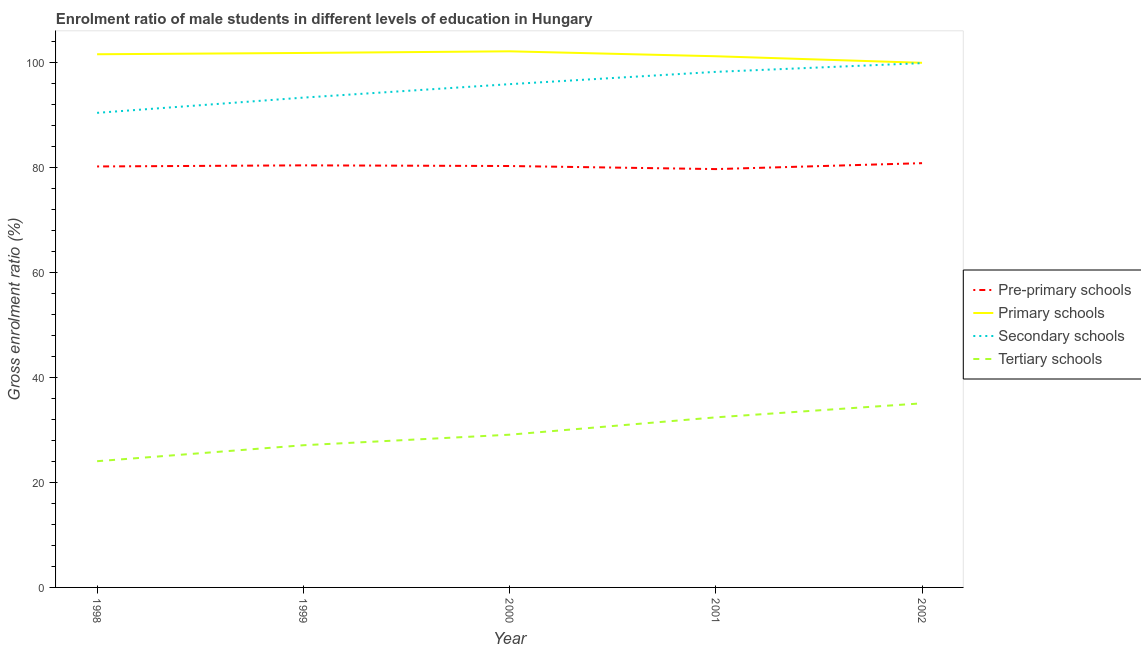How many different coloured lines are there?
Provide a short and direct response. 4. Does the line corresponding to gross enrolment ratio(female) in pre-primary schools intersect with the line corresponding to gross enrolment ratio(female) in tertiary schools?
Give a very brief answer. No. Is the number of lines equal to the number of legend labels?
Offer a terse response. Yes. What is the gross enrolment ratio(female) in pre-primary schools in 2001?
Offer a very short reply. 79.65. Across all years, what is the maximum gross enrolment ratio(female) in pre-primary schools?
Make the answer very short. 80.78. Across all years, what is the minimum gross enrolment ratio(female) in primary schools?
Ensure brevity in your answer.  99.89. What is the total gross enrolment ratio(female) in primary schools in the graph?
Your answer should be compact. 506.36. What is the difference between the gross enrolment ratio(female) in pre-primary schools in 1999 and that in 2000?
Your answer should be compact. 0.13. What is the difference between the gross enrolment ratio(female) in pre-primary schools in 2000 and the gross enrolment ratio(female) in primary schools in 1998?
Make the answer very short. -21.28. What is the average gross enrolment ratio(female) in primary schools per year?
Your answer should be compact. 101.27. In the year 2000, what is the difference between the gross enrolment ratio(female) in secondary schools and gross enrolment ratio(female) in pre-primary schools?
Provide a succinct answer. 15.58. What is the ratio of the gross enrolment ratio(female) in tertiary schools in 1999 to that in 2002?
Make the answer very short. 0.77. Is the gross enrolment ratio(female) in secondary schools in 1998 less than that in 2001?
Offer a terse response. Yes. Is the difference between the gross enrolment ratio(female) in tertiary schools in 1999 and 2002 greater than the difference between the gross enrolment ratio(female) in pre-primary schools in 1999 and 2002?
Provide a short and direct response. No. What is the difference between the highest and the second highest gross enrolment ratio(female) in primary schools?
Offer a terse response. 0.31. What is the difference between the highest and the lowest gross enrolment ratio(female) in secondary schools?
Offer a very short reply. 9.47. Is the sum of the gross enrolment ratio(female) in pre-primary schools in 2001 and 2002 greater than the maximum gross enrolment ratio(female) in primary schools across all years?
Offer a very short reply. Yes. Is it the case that in every year, the sum of the gross enrolment ratio(female) in secondary schools and gross enrolment ratio(female) in primary schools is greater than the sum of gross enrolment ratio(female) in pre-primary schools and gross enrolment ratio(female) in tertiary schools?
Make the answer very short. Yes. How many lines are there?
Provide a succinct answer. 4. What is the difference between two consecutive major ticks on the Y-axis?
Give a very brief answer. 20. Does the graph contain any zero values?
Offer a terse response. No. Where does the legend appear in the graph?
Provide a short and direct response. Center right. How are the legend labels stacked?
Provide a short and direct response. Vertical. What is the title of the graph?
Make the answer very short. Enrolment ratio of male students in different levels of education in Hungary. Does "Secondary general" appear as one of the legend labels in the graph?
Offer a terse response. No. What is the label or title of the X-axis?
Provide a short and direct response. Year. What is the Gross enrolment ratio (%) in Pre-primary schools in 1998?
Offer a terse response. 80.15. What is the Gross enrolment ratio (%) of Primary schools in 1998?
Offer a terse response. 101.51. What is the Gross enrolment ratio (%) in Secondary schools in 1998?
Make the answer very short. 90.36. What is the Gross enrolment ratio (%) in Tertiary schools in 1998?
Your answer should be very brief. 24.03. What is the Gross enrolment ratio (%) of Pre-primary schools in 1999?
Give a very brief answer. 80.36. What is the Gross enrolment ratio (%) in Primary schools in 1999?
Ensure brevity in your answer.  101.76. What is the Gross enrolment ratio (%) in Secondary schools in 1999?
Give a very brief answer. 93.26. What is the Gross enrolment ratio (%) in Tertiary schools in 1999?
Provide a succinct answer. 27.07. What is the Gross enrolment ratio (%) of Pre-primary schools in 2000?
Offer a terse response. 80.23. What is the Gross enrolment ratio (%) in Primary schools in 2000?
Your response must be concise. 102.07. What is the Gross enrolment ratio (%) in Secondary schools in 2000?
Make the answer very short. 95.82. What is the Gross enrolment ratio (%) of Tertiary schools in 2000?
Your answer should be compact. 29.08. What is the Gross enrolment ratio (%) in Pre-primary schools in 2001?
Ensure brevity in your answer.  79.65. What is the Gross enrolment ratio (%) in Primary schools in 2001?
Your response must be concise. 101.13. What is the Gross enrolment ratio (%) of Secondary schools in 2001?
Offer a terse response. 98.16. What is the Gross enrolment ratio (%) in Tertiary schools in 2001?
Provide a succinct answer. 32.38. What is the Gross enrolment ratio (%) of Pre-primary schools in 2002?
Ensure brevity in your answer.  80.78. What is the Gross enrolment ratio (%) of Primary schools in 2002?
Offer a terse response. 99.89. What is the Gross enrolment ratio (%) in Secondary schools in 2002?
Provide a succinct answer. 99.82. What is the Gross enrolment ratio (%) of Tertiary schools in 2002?
Make the answer very short. 35.05. Across all years, what is the maximum Gross enrolment ratio (%) in Pre-primary schools?
Offer a terse response. 80.78. Across all years, what is the maximum Gross enrolment ratio (%) in Primary schools?
Provide a succinct answer. 102.07. Across all years, what is the maximum Gross enrolment ratio (%) in Secondary schools?
Make the answer very short. 99.82. Across all years, what is the maximum Gross enrolment ratio (%) in Tertiary schools?
Offer a very short reply. 35.05. Across all years, what is the minimum Gross enrolment ratio (%) of Pre-primary schools?
Offer a very short reply. 79.65. Across all years, what is the minimum Gross enrolment ratio (%) of Primary schools?
Your response must be concise. 99.89. Across all years, what is the minimum Gross enrolment ratio (%) of Secondary schools?
Provide a succinct answer. 90.36. Across all years, what is the minimum Gross enrolment ratio (%) in Tertiary schools?
Your response must be concise. 24.03. What is the total Gross enrolment ratio (%) in Pre-primary schools in the graph?
Offer a very short reply. 401.17. What is the total Gross enrolment ratio (%) of Primary schools in the graph?
Give a very brief answer. 506.36. What is the total Gross enrolment ratio (%) of Secondary schools in the graph?
Keep it short and to the point. 477.41. What is the total Gross enrolment ratio (%) of Tertiary schools in the graph?
Provide a short and direct response. 147.62. What is the difference between the Gross enrolment ratio (%) of Pre-primary schools in 1998 and that in 1999?
Offer a very short reply. -0.21. What is the difference between the Gross enrolment ratio (%) in Primary schools in 1998 and that in 1999?
Your response must be concise. -0.25. What is the difference between the Gross enrolment ratio (%) in Secondary schools in 1998 and that in 1999?
Your answer should be very brief. -2.9. What is the difference between the Gross enrolment ratio (%) of Tertiary schools in 1998 and that in 1999?
Give a very brief answer. -3.04. What is the difference between the Gross enrolment ratio (%) of Pre-primary schools in 1998 and that in 2000?
Your answer should be compact. -0.08. What is the difference between the Gross enrolment ratio (%) of Primary schools in 1998 and that in 2000?
Offer a terse response. -0.56. What is the difference between the Gross enrolment ratio (%) of Secondary schools in 1998 and that in 2000?
Keep it short and to the point. -5.46. What is the difference between the Gross enrolment ratio (%) in Tertiary schools in 1998 and that in 2000?
Provide a short and direct response. -5.05. What is the difference between the Gross enrolment ratio (%) of Pre-primary schools in 1998 and that in 2001?
Your response must be concise. 0.5. What is the difference between the Gross enrolment ratio (%) in Primary schools in 1998 and that in 2001?
Provide a succinct answer. 0.38. What is the difference between the Gross enrolment ratio (%) of Secondary schools in 1998 and that in 2001?
Give a very brief answer. -7.8. What is the difference between the Gross enrolment ratio (%) of Tertiary schools in 1998 and that in 2001?
Your answer should be compact. -8.35. What is the difference between the Gross enrolment ratio (%) of Pre-primary schools in 1998 and that in 2002?
Your response must be concise. -0.63. What is the difference between the Gross enrolment ratio (%) in Primary schools in 1998 and that in 2002?
Give a very brief answer. 1.63. What is the difference between the Gross enrolment ratio (%) of Secondary schools in 1998 and that in 2002?
Keep it short and to the point. -9.47. What is the difference between the Gross enrolment ratio (%) of Tertiary schools in 1998 and that in 2002?
Provide a short and direct response. -11.02. What is the difference between the Gross enrolment ratio (%) of Pre-primary schools in 1999 and that in 2000?
Keep it short and to the point. 0.13. What is the difference between the Gross enrolment ratio (%) of Primary schools in 1999 and that in 2000?
Provide a short and direct response. -0.31. What is the difference between the Gross enrolment ratio (%) in Secondary schools in 1999 and that in 2000?
Provide a short and direct response. -2.56. What is the difference between the Gross enrolment ratio (%) in Tertiary schools in 1999 and that in 2000?
Offer a very short reply. -2.01. What is the difference between the Gross enrolment ratio (%) of Pre-primary schools in 1999 and that in 2001?
Your answer should be compact. 0.71. What is the difference between the Gross enrolment ratio (%) in Primary schools in 1999 and that in 2001?
Your answer should be compact. 0.63. What is the difference between the Gross enrolment ratio (%) of Secondary schools in 1999 and that in 2001?
Keep it short and to the point. -4.9. What is the difference between the Gross enrolment ratio (%) in Tertiary schools in 1999 and that in 2001?
Provide a short and direct response. -5.31. What is the difference between the Gross enrolment ratio (%) in Pre-primary schools in 1999 and that in 2002?
Make the answer very short. -0.42. What is the difference between the Gross enrolment ratio (%) in Primary schools in 1999 and that in 2002?
Give a very brief answer. 1.87. What is the difference between the Gross enrolment ratio (%) in Secondary schools in 1999 and that in 2002?
Provide a short and direct response. -6.57. What is the difference between the Gross enrolment ratio (%) in Tertiary schools in 1999 and that in 2002?
Ensure brevity in your answer.  -7.98. What is the difference between the Gross enrolment ratio (%) in Pre-primary schools in 2000 and that in 2001?
Provide a succinct answer. 0.58. What is the difference between the Gross enrolment ratio (%) of Primary schools in 2000 and that in 2001?
Your answer should be compact. 0.94. What is the difference between the Gross enrolment ratio (%) in Secondary schools in 2000 and that in 2001?
Your answer should be compact. -2.34. What is the difference between the Gross enrolment ratio (%) of Tertiary schools in 2000 and that in 2001?
Offer a very short reply. -3.3. What is the difference between the Gross enrolment ratio (%) of Pre-primary schools in 2000 and that in 2002?
Your answer should be very brief. -0.54. What is the difference between the Gross enrolment ratio (%) in Primary schools in 2000 and that in 2002?
Ensure brevity in your answer.  2.18. What is the difference between the Gross enrolment ratio (%) of Secondary schools in 2000 and that in 2002?
Give a very brief answer. -4.01. What is the difference between the Gross enrolment ratio (%) of Tertiary schools in 2000 and that in 2002?
Provide a succinct answer. -5.97. What is the difference between the Gross enrolment ratio (%) of Pre-primary schools in 2001 and that in 2002?
Make the answer very short. -1.13. What is the difference between the Gross enrolment ratio (%) of Primary schools in 2001 and that in 2002?
Offer a terse response. 1.24. What is the difference between the Gross enrolment ratio (%) of Secondary schools in 2001 and that in 2002?
Make the answer very short. -1.66. What is the difference between the Gross enrolment ratio (%) in Tertiary schools in 2001 and that in 2002?
Give a very brief answer. -2.67. What is the difference between the Gross enrolment ratio (%) in Pre-primary schools in 1998 and the Gross enrolment ratio (%) in Primary schools in 1999?
Provide a succinct answer. -21.61. What is the difference between the Gross enrolment ratio (%) in Pre-primary schools in 1998 and the Gross enrolment ratio (%) in Secondary schools in 1999?
Provide a short and direct response. -13.11. What is the difference between the Gross enrolment ratio (%) in Pre-primary schools in 1998 and the Gross enrolment ratio (%) in Tertiary schools in 1999?
Keep it short and to the point. 53.08. What is the difference between the Gross enrolment ratio (%) in Primary schools in 1998 and the Gross enrolment ratio (%) in Secondary schools in 1999?
Give a very brief answer. 8.26. What is the difference between the Gross enrolment ratio (%) in Primary schools in 1998 and the Gross enrolment ratio (%) in Tertiary schools in 1999?
Provide a short and direct response. 74.44. What is the difference between the Gross enrolment ratio (%) in Secondary schools in 1998 and the Gross enrolment ratio (%) in Tertiary schools in 1999?
Keep it short and to the point. 63.29. What is the difference between the Gross enrolment ratio (%) in Pre-primary schools in 1998 and the Gross enrolment ratio (%) in Primary schools in 2000?
Ensure brevity in your answer.  -21.92. What is the difference between the Gross enrolment ratio (%) in Pre-primary schools in 1998 and the Gross enrolment ratio (%) in Secondary schools in 2000?
Make the answer very short. -15.67. What is the difference between the Gross enrolment ratio (%) of Pre-primary schools in 1998 and the Gross enrolment ratio (%) of Tertiary schools in 2000?
Make the answer very short. 51.07. What is the difference between the Gross enrolment ratio (%) in Primary schools in 1998 and the Gross enrolment ratio (%) in Secondary schools in 2000?
Ensure brevity in your answer.  5.7. What is the difference between the Gross enrolment ratio (%) of Primary schools in 1998 and the Gross enrolment ratio (%) of Tertiary schools in 2000?
Make the answer very short. 72.43. What is the difference between the Gross enrolment ratio (%) of Secondary schools in 1998 and the Gross enrolment ratio (%) of Tertiary schools in 2000?
Provide a short and direct response. 61.28. What is the difference between the Gross enrolment ratio (%) in Pre-primary schools in 1998 and the Gross enrolment ratio (%) in Primary schools in 2001?
Provide a short and direct response. -20.98. What is the difference between the Gross enrolment ratio (%) of Pre-primary schools in 1998 and the Gross enrolment ratio (%) of Secondary schools in 2001?
Ensure brevity in your answer.  -18.01. What is the difference between the Gross enrolment ratio (%) in Pre-primary schools in 1998 and the Gross enrolment ratio (%) in Tertiary schools in 2001?
Your answer should be compact. 47.77. What is the difference between the Gross enrolment ratio (%) of Primary schools in 1998 and the Gross enrolment ratio (%) of Secondary schools in 2001?
Offer a terse response. 3.35. What is the difference between the Gross enrolment ratio (%) in Primary schools in 1998 and the Gross enrolment ratio (%) in Tertiary schools in 2001?
Offer a terse response. 69.13. What is the difference between the Gross enrolment ratio (%) of Secondary schools in 1998 and the Gross enrolment ratio (%) of Tertiary schools in 2001?
Your answer should be compact. 57.97. What is the difference between the Gross enrolment ratio (%) in Pre-primary schools in 1998 and the Gross enrolment ratio (%) in Primary schools in 2002?
Your answer should be very brief. -19.74. What is the difference between the Gross enrolment ratio (%) of Pre-primary schools in 1998 and the Gross enrolment ratio (%) of Secondary schools in 2002?
Ensure brevity in your answer.  -19.67. What is the difference between the Gross enrolment ratio (%) in Pre-primary schools in 1998 and the Gross enrolment ratio (%) in Tertiary schools in 2002?
Offer a terse response. 45.1. What is the difference between the Gross enrolment ratio (%) in Primary schools in 1998 and the Gross enrolment ratio (%) in Secondary schools in 2002?
Ensure brevity in your answer.  1.69. What is the difference between the Gross enrolment ratio (%) of Primary schools in 1998 and the Gross enrolment ratio (%) of Tertiary schools in 2002?
Your answer should be compact. 66.46. What is the difference between the Gross enrolment ratio (%) of Secondary schools in 1998 and the Gross enrolment ratio (%) of Tertiary schools in 2002?
Make the answer very short. 55.31. What is the difference between the Gross enrolment ratio (%) of Pre-primary schools in 1999 and the Gross enrolment ratio (%) of Primary schools in 2000?
Keep it short and to the point. -21.71. What is the difference between the Gross enrolment ratio (%) in Pre-primary schools in 1999 and the Gross enrolment ratio (%) in Secondary schools in 2000?
Your answer should be very brief. -15.46. What is the difference between the Gross enrolment ratio (%) in Pre-primary schools in 1999 and the Gross enrolment ratio (%) in Tertiary schools in 2000?
Make the answer very short. 51.28. What is the difference between the Gross enrolment ratio (%) of Primary schools in 1999 and the Gross enrolment ratio (%) of Secondary schools in 2000?
Offer a very short reply. 5.94. What is the difference between the Gross enrolment ratio (%) in Primary schools in 1999 and the Gross enrolment ratio (%) in Tertiary schools in 2000?
Your answer should be very brief. 72.68. What is the difference between the Gross enrolment ratio (%) of Secondary schools in 1999 and the Gross enrolment ratio (%) of Tertiary schools in 2000?
Ensure brevity in your answer.  64.18. What is the difference between the Gross enrolment ratio (%) of Pre-primary schools in 1999 and the Gross enrolment ratio (%) of Primary schools in 2001?
Your answer should be very brief. -20.77. What is the difference between the Gross enrolment ratio (%) in Pre-primary schools in 1999 and the Gross enrolment ratio (%) in Secondary schools in 2001?
Keep it short and to the point. -17.8. What is the difference between the Gross enrolment ratio (%) in Pre-primary schools in 1999 and the Gross enrolment ratio (%) in Tertiary schools in 2001?
Offer a very short reply. 47.98. What is the difference between the Gross enrolment ratio (%) of Primary schools in 1999 and the Gross enrolment ratio (%) of Secondary schools in 2001?
Keep it short and to the point. 3.6. What is the difference between the Gross enrolment ratio (%) of Primary schools in 1999 and the Gross enrolment ratio (%) of Tertiary schools in 2001?
Your answer should be compact. 69.38. What is the difference between the Gross enrolment ratio (%) of Secondary schools in 1999 and the Gross enrolment ratio (%) of Tertiary schools in 2001?
Provide a succinct answer. 60.87. What is the difference between the Gross enrolment ratio (%) of Pre-primary schools in 1999 and the Gross enrolment ratio (%) of Primary schools in 2002?
Provide a succinct answer. -19.53. What is the difference between the Gross enrolment ratio (%) in Pre-primary schools in 1999 and the Gross enrolment ratio (%) in Secondary schools in 2002?
Keep it short and to the point. -19.46. What is the difference between the Gross enrolment ratio (%) of Pre-primary schools in 1999 and the Gross enrolment ratio (%) of Tertiary schools in 2002?
Give a very brief answer. 45.31. What is the difference between the Gross enrolment ratio (%) in Primary schools in 1999 and the Gross enrolment ratio (%) in Secondary schools in 2002?
Keep it short and to the point. 1.94. What is the difference between the Gross enrolment ratio (%) of Primary schools in 1999 and the Gross enrolment ratio (%) of Tertiary schools in 2002?
Give a very brief answer. 66.71. What is the difference between the Gross enrolment ratio (%) in Secondary schools in 1999 and the Gross enrolment ratio (%) in Tertiary schools in 2002?
Give a very brief answer. 58.2. What is the difference between the Gross enrolment ratio (%) in Pre-primary schools in 2000 and the Gross enrolment ratio (%) in Primary schools in 2001?
Ensure brevity in your answer.  -20.9. What is the difference between the Gross enrolment ratio (%) of Pre-primary schools in 2000 and the Gross enrolment ratio (%) of Secondary schools in 2001?
Keep it short and to the point. -17.93. What is the difference between the Gross enrolment ratio (%) of Pre-primary schools in 2000 and the Gross enrolment ratio (%) of Tertiary schools in 2001?
Your answer should be very brief. 47.85. What is the difference between the Gross enrolment ratio (%) in Primary schools in 2000 and the Gross enrolment ratio (%) in Secondary schools in 2001?
Your answer should be compact. 3.91. What is the difference between the Gross enrolment ratio (%) in Primary schools in 2000 and the Gross enrolment ratio (%) in Tertiary schools in 2001?
Provide a succinct answer. 69.69. What is the difference between the Gross enrolment ratio (%) of Secondary schools in 2000 and the Gross enrolment ratio (%) of Tertiary schools in 2001?
Keep it short and to the point. 63.44. What is the difference between the Gross enrolment ratio (%) in Pre-primary schools in 2000 and the Gross enrolment ratio (%) in Primary schools in 2002?
Make the answer very short. -19.65. What is the difference between the Gross enrolment ratio (%) in Pre-primary schools in 2000 and the Gross enrolment ratio (%) in Secondary schools in 2002?
Offer a very short reply. -19.59. What is the difference between the Gross enrolment ratio (%) of Pre-primary schools in 2000 and the Gross enrolment ratio (%) of Tertiary schools in 2002?
Your response must be concise. 45.18. What is the difference between the Gross enrolment ratio (%) of Primary schools in 2000 and the Gross enrolment ratio (%) of Secondary schools in 2002?
Ensure brevity in your answer.  2.25. What is the difference between the Gross enrolment ratio (%) of Primary schools in 2000 and the Gross enrolment ratio (%) of Tertiary schools in 2002?
Ensure brevity in your answer.  67.02. What is the difference between the Gross enrolment ratio (%) in Secondary schools in 2000 and the Gross enrolment ratio (%) in Tertiary schools in 2002?
Ensure brevity in your answer.  60.77. What is the difference between the Gross enrolment ratio (%) in Pre-primary schools in 2001 and the Gross enrolment ratio (%) in Primary schools in 2002?
Provide a short and direct response. -20.24. What is the difference between the Gross enrolment ratio (%) in Pre-primary schools in 2001 and the Gross enrolment ratio (%) in Secondary schools in 2002?
Provide a succinct answer. -20.17. What is the difference between the Gross enrolment ratio (%) in Pre-primary schools in 2001 and the Gross enrolment ratio (%) in Tertiary schools in 2002?
Provide a short and direct response. 44.6. What is the difference between the Gross enrolment ratio (%) in Primary schools in 2001 and the Gross enrolment ratio (%) in Secondary schools in 2002?
Provide a succinct answer. 1.31. What is the difference between the Gross enrolment ratio (%) in Primary schools in 2001 and the Gross enrolment ratio (%) in Tertiary schools in 2002?
Offer a terse response. 66.08. What is the difference between the Gross enrolment ratio (%) of Secondary schools in 2001 and the Gross enrolment ratio (%) of Tertiary schools in 2002?
Provide a succinct answer. 63.11. What is the average Gross enrolment ratio (%) of Pre-primary schools per year?
Give a very brief answer. 80.23. What is the average Gross enrolment ratio (%) in Primary schools per year?
Give a very brief answer. 101.27. What is the average Gross enrolment ratio (%) in Secondary schools per year?
Give a very brief answer. 95.48. What is the average Gross enrolment ratio (%) in Tertiary schools per year?
Your answer should be very brief. 29.52. In the year 1998, what is the difference between the Gross enrolment ratio (%) of Pre-primary schools and Gross enrolment ratio (%) of Primary schools?
Offer a very short reply. -21.36. In the year 1998, what is the difference between the Gross enrolment ratio (%) of Pre-primary schools and Gross enrolment ratio (%) of Secondary schools?
Offer a terse response. -10.21. In the year 1998, what is the difference between the Gross enrolment ratio (%) in Pre-primary schools and Gross enrolment ratio (%) in Tertiary schools?
Offer a terse response. 56.12. In the year 1998, what is the difference between the Gross enrolment ratio (%) in Primary schools and Gross enrolment ratio (%) in Secondary schools?
Keep it short and to the point. 11.16. In the year 1998, what is the difference between the Gross enrolment ratio (%) in Primary schools and Gross enrolment ratio (%) in Tertiary schools?
Keep it short and to the point. 77.48. In the year 1998, what is the difference between the Gross enrolment ratio (%) of Secondary schools and Gross enrolment ratio (%) of Tertiary schools?
Your answer should be very brief. 66.33. In the year 1999, what is the difference between the Gross enrolment ratio (%) in Pre-primary schools and Gross enrolment ratio (%) in Primary schools?
Keep it short and to the point. -21.4. In the year 1999, what is the difference between the Gross enrolment ratio (%) of Pre-primary schools and Gross enrolment ratio (%) of Secondary schools?
Make the answer very short. -12.9. In the year 1999, what is the difference between the Gross enrolment ratio (%) in Pre-primary schools and Gross enrolment ratio (%) in Tertiary schools?
Make the answer very short. 53.29. In the year 1999, what is the difference between the Gross enrolment ratio (%) in Primary schools and Gross enrolment ratio (%) in Secondary schools?
Provide a succinct answer. 8.5. In the year 1999, what is the difference between the Gross enrolment ratio (%) of Primary schools and Gross enrolment ratio (%) of Tertiary schools?
Offer a terse response. 74.69. In the year 1999, what is the difference between the Gross enrolment ratio (%) in Secondary schools and Gross enrolment ratio (%) in Tertiary schools?
Ensure brevity in your answer.  66.19. In the year 2000, what is the difference between the Gross enrolment ratio (%) of Pre-primary schools and Gross enrolment ratio (%) of Primary schools?
Your answer should be very brief. -21.84. In the year 2000, what is the difference between the Gross enrolment ratio (%) in Pre-primary schools and Gross enrolment ratio (%) in Secondary schools?
Keep it short and to the point. -15.58. In the year 2000, what is the difference between the Gross enrolment ratio (%) in Pre-primary schools and Gross enrolment ratio (%) in Tertiary schools?
Provide a succinct answer. 51.15. In the year 2000, what is the difference between the Gross enrolment ratio (%) in Primary schools and Gross enrolment ratio (%) in Secondary schools?
Provide a succinct answer. 6.25. In the year 2000, what is the difference between the Gross enrolment ratio (%) of Primary schools and Gross enrolment ratio (%) of Tertiary schools?
Your response must be concise. 72.99. In the year 2000, what is the difference between the Gross enrolment ratio (%) of Secondary schools and Gross enrolment ratio (%) of Tertiary schools?
Ensure brevity in your answer.  66.74. In the year 2001, what is the difference between the Gross enrolment ratio (%) of Pre-primary schools and Gross enrolment ratio (%) of Primary schools?
Your answer should be very brief. -21.48. In the year 2001, what is the difference between the Gross enrolment ratio (%) in Pre-primary schools and Gross enrolment ratio (%) in Secondary schools?
Make the answer very short. -18.51. In the year 2001, what is the difference between the Gross enrolment ratio (%) in Pre-primary schools and Gross enrolment ratio (%) in Tertiary schools?
Offer a terse response. 47.27. In the year 2001, what is the difference between the Gross enrolment ratio (%) in Primary schools and Gross enrolment ratio (%) in Secondary schools?
Offer a very short reply. 2.97. In the year 2001, what is the difference between the Gross enrolment ratio (%) in Primary schools and Gross enrolment ratio (%) in Tertiary schools?
Offer a terse response. 68.75. In the year 2001, what is the difference between the Gross enrolment ratio (%) of Secondary schools and Gross enrolment ratio (%) of Tertiary schools?
Your response must be concise. 65.78. In the year 2002, what is the difference between the Gross enrolment ratio (%) in Pre-primary schools and Gross enrolment ratio (%) in Primary schools?
Your answer should be compact. -19.11. In the year 2002, what is the difference between the Gross enrolment ratio (%) in Pre-primary schools and Gross enrolment ratio (%) in Secondary schools?
Offer a very short reply. -19.05. In the year 2002, what is the difference between the Gross enrolment ratio (%) of Pre-primary schools and Gross enrolment ratio (%) of Tertiary schools?
Offer a very short reply. 45.72. In the year 2002, what is the difference between the Gross enrolment ratio (%) of Primary schools and Gross enrolment ratio (%) of Secondary schools?
Keep it short and to the point. 0.06. In the year 2002, what is the difference between the Gross enrolment ratio (%) of Primary schools and Gross enrolment ratio (%) of Tertiary schools?
Your answer should be compact. 64.83. In the year 2002, what is the difference between the Gross enrolment ratio (%) in Secondary schools and Gross enrolment ratio (%) in Tertiary schools?
Your answer should be compact. 64.77. What is the ratio of the Gross enrolment ratio (%) of Secondary schools in 1998 to that in 1999?
Provide a succinct answer. 0.97. What is the ratio of the Gross enrolment ratio (%) of Tertiary schools in 1998 to that in 1999?
Keep it short and to the point. 0.89. What is the ratio of the Gross enrolment ratio (%) in Secondary schools in 1998 to that in 2000?
Your answer should be compact. 0.94. What is the ratio of the Gross enrolment ratio (%) in Tertiary schools in 1998 to that in 2000?
Offer a terse response. 0.83. What is the ratio of the Gross enrolment ratio (%) of Primary schools in 1998 to that in 2001?
Ensure brevity in your answer.  1. What is the ratio of the Gross enrolment ratio (%) of Secondary schools in 1998 to that in 2001?
Your answer should be very brief. 0.92. What is the ratio of the Gross enrolment ratio (%) of Tertiary schools in 1998 to that in 2001?
Your response must be concise. 0.74. What is the ratio of the Gross enrolment ratio (%) of Primary schools in 1998 to that in 2002?
Make the answer very short. 1.02. What is the ratio of the Gross enrolment ratio (%) in Secondary schools in 1998 to that in 2002?
Give a very brief answer. 0.91. What is the ratio of the Gross enrolment ratio (%) of Tertiary schools in 1998 to that in 2002?
Make the answer very short. 0.69. What is the ratio of the Gross enrolment ratio (%) of Pre-primary schools in 1999 to that in 2000?
Your answer should be very brief. 1. What is the ratio of the Gross enrolment ratio (%) of Primary schools in 1999 to that in 2000?
Your answer should be compact. 1. What is the ratio of the Gross enrolment ratio (%) in Secondary schools in 1999 to that in 2000?
Give a very brief answer. 0.97. What is the ratio of the Gross enrolment ratio (%) of Tertiary schools in 1999 to that in 2000?
Your answer should be compact. 0.93. What is the ratio of the Gross enrolment ratio (%) of Pre-primary schools in 1999 to that in 2001?
Give a very brief answer. 1.01. What is the ratio of the Gross enrolment ratio (%) of Tertiary schools in 1999 to that in 2001?
Your answer should be compact. 0.84. What is the ratio of the Gross enrolment ratio (%) of Pre-primary schools in 1999 to that in 2002?
Provide a short and direct response. 0.99. What is the ratio of the Gross enrolment ratio (%) of Primary schools in 1999 to that in 2002?
Ensure brevity in your answer.  1.02. What is the ratio of the Gross enrolment ratio (%) in Secondary schools in 1999 to that in 2002?
Make the answer very short. 0.93. What is the ratio of the Gross enrolment ratio (%) of Tertiary schools in 1999 to that in 2002?
Offer a terse response. 0.77. What is the ratio of the Gross enrolment ratio (%) of Pre-primary schools in 2000 to that in 2001?
Your answer should be compact. 1.01. What is the ratio of the Gross enrolment ratio (%) of Primary schools in 2000 to that in 2001?
Ensure brevity in your answer.  1.01. What is the ratio of the Gross enrolment ratio (%) in Secondary schools in 2000 to that in 2001?
Provide a succinct answer. 0.98. What is the ratio of the Gross enrolment ratio (%) of Tertiary schools in 2000 to that in 2001?
Your answer should be very brief. 0.9. What is the ratio of the Gross enrolment ratio (%) of Primary schools in 2000 to that in 2002?
Keep it short and to the point. 1.02. What is the ratio of the Gross enrolment ratio (%) of Secondary schools in 2000 to that in 2002?
Offer a very short reply. 0.96. What is the ratio of the Gross enrolment ratio (%) in Tertiary schools in 2000 to that in 2002?
Keep it short and to the point. 0.83. What is the ratio of the Gross enrolment ratio (%) in Primary schools in 2001 to that in 2002?
Keep it short and to the point. 1.01. What is the ratio of the Gross enrolment ratio (%) in Secondary schools in 2001 to that in 2002?
Offer a terse response. 0.98. What is the ratio of the Gross enrolment ratio (%) in Tertiary schools in 2001 to that in 2002?
Offer a very short reply. 0.92. What is the difference between the highest and the second highest Gross enrolment ratio (%) in Pre-primary schools?
Offer a terse response. 0.42. What is the difference between the highest and the second highest Gross enrolment ratio (%) in Primary schools?
Make the answer very short. 0.31. What is the difference between the highest and the second highest Gross enrolment ratio (%) of Secondary schools?
Offer a very short reply. 1.66. What is the difference between the highest and the second highest Gross enrolment ratio (%) of Tertiary schools?
Provide a succinct answer. 2.67. What is the difference between the highest and the lowest Gross enrolment ratio (%) in Pre-primary schools?
Your answer should be very brief. 1.13. What is the difference between the highest and the lowest Gross enrolment ratio (%) of Primary schools?
Provide a short and direct response. 2.18. What is the difference between the highest and the lowest Gross enrolment ratio (%) of Secondary schools?
Offer a terse response. 9.47. What is the difference between the highest and the lowest Gross enrolment ratio (%) of Tertiary schools?
Provide a succinct answer. 11.02. 